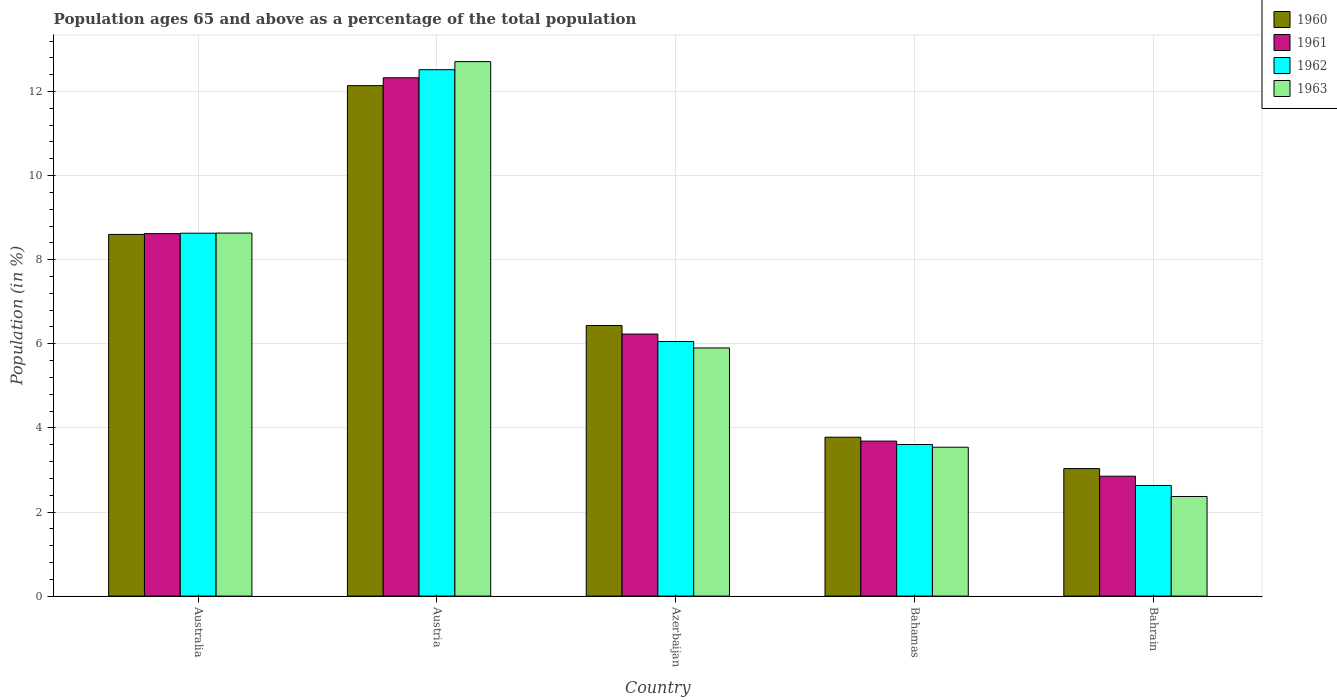How many groups of bars are there?
Keep it short and to the point. 5. How many bars are there on the 2nd tick from the left?
Make the answer very short. 4. How many bars are there on the 4th tick from the right?
Keep it short and to the point. 4. What is the label of the 2nd group of bars from the left?
Give a very brief answer. Austria. In how many cases, is the number of bars for a given country not equal to the number of legend labels?
Offer a very short reply. 0. What is the percentage of the population ages 65 and above in 1963 in Austria?
Ensure brevity in your answer.  12.71. Across all countries, what is the maximum percentage of the population ages 65 and above in 1962?
Give a very brief answer. 12.52. Across all countries, what is the minimum percentage of the population ages 65 and above in 1961?
Offer a terse response. 2.85. In which country was the percentage of the population ages 65 and above in 1962 maximum?
Offer a very short reply. Austria. In which country was the percentage of the population ages 65 and above in 1963 minimum?
Your answer should be compact. Bahrain. What is the total percentage of the population ages 65 and above in 1960 in the graph?
Offer a very short reply. 33.99. What is the difference between the percentage of the population ages 65 and above in 1960 in Bahamas and that in Bahrain?
Ensure brevity in your answer.  0.75. What is the difference between the percentage of the population ages 65 and above in 1963 in Australia and the percentage of the population ages 65 and above in 1960 in Azerbaijan?
Give a very brief answer. 2.2. What is the average percentage of the population ages 65 and above in 1960 per country?
Make the answer very short. 6.8. What is the difference between the percentage of the population ages 65 and above of/in 1961 and percentage of the population ages 65 and above of/in 1963 in Austria?
Offer a terse response. -0.38. What is the ratio of the percentage of the population ages 65 and above in 1960 in Bahamas to that in Bahrain?
Offer a very short reply. 1.25. Is the percentage of the population ages 65 and above in 1961 in Azerbaijan less than that in Bahamas?
Your answer should be very brief. No. Is the difference between the percentage of the population ages 65 and above in 1961 in Austria and Bahrain greater than the difference between the percentage of the population ages 65 and above in 1963 in Austria and Bahrain?
Make the answer very short. No. What is the difference between the highest and the second highest percentage of the population ages 65 and above in 1962?
Ensure brevity in your answer.  -3.89. What is the difference between the highest and the lowest percentage of the population ages 65 and above in 1960?
Keep it short and to the point. 9.11. In how many countries, is the percentage of the population ages 65 and above in 1961 greater than the average percentage of the population ages 65 and above in 1961 taken over all countries?
Your response must be concise. 2. Is the sum of the percentage of the population ages 65 and above in 1960 in Australia and Bahamas greater than the maximum percentage of the population ages 65 and above in 1961 across all countries?
Keep it short and to the point. Yes. What does the 2nd bar from the left in Azerbaijan represents?
Offer a terse response. 1961. What does the 4th bar from the right in Azerbaijan represents?
Make the answer very short. 1960. How many bars are there?
Give a very brief answer. 20. Are all the bars in the graph horizontal?
Ensure brevity in your answer.  No. What is the difference between two consecutive major ticks on the Y-axis?
Provide a succinct answer. 2. Are the values on the major ticks of Y-axis written in scientific E-notation?
Keep it short and to the point. No. Does the graph contain grids?
Give a very brief answer. Yes. How are the legend labels stacked?
Give a very brief answer. Vertical. What is the title of the graph?
Your answer should be compact. Population ages 65 and above as a percentage of the total population. Does "1966" appear as one of the legend labels in the graph?
Offer a terse response. No. What is the label or title of the X-axis?
Ensure brevity in your answer.  Country. What is the Population (in %) in 1960 in Australia?
Your response must be concise. 8.6. What is the Population (in %) of 1961 in Australia?
Provide a short and direct response. 8.62. What is the Population (in %) of 1962 in Australia?
Offer a terse response. 8.63. What is the Population (in %) of 1963 in Australia?
Offer a terse response. 8.63. What is the Population (in %) in 1960 in Austria?
Your answer should be very brief. 12.14. What is the Population (in %) in 1961 in Austria?
Make the answer very short. 12.33. What is the Population (in %) of 1962 in Austria?
Provide a short and direct response. 12.52. What is the Population (in %) in 1963 in Austria?
Your response must be concise. 12.71. What is the Population (in %) in 1960 in Azerbaijan?
Keep it short and to the point. 6.43. What is the Population (in %) of 1961 in Azerbaijan?
Your response must be concise. 6.23. What is the Population (in %) of 1962 in Azerbaijan?
Your answer should be very brief. 6.06. What is the Population (in %) of 1963 in Azerbaijan?
Offer a very short reply. 5.9. What is the Population (in %) of 1960 in Bahamas?
Keep it short and to the point. 3.78. What is the Population (in %) of 1961 in Bahamas?
Offer a very short reply. 3.69. What is the Population (in %) in 1962 in Bahamas?
Offer a very short reply. 3.6. What is the Population (in %) in 1963 in Bahamas?
Your response must be concise. 3.54. What is the Population (in %) of 1960 in Bahrain?
Ensure brevity in your answer.  3.03. What is the Population (in %) of 1961 in Bahrain?
Offer a very short reply. 2.85. What is the Population (in %) in 1962 in Bahrain?
Ensure brevity in your answer.  2.63. What is the Population (in %) in 1963 in Bahrain?
Your answer should be compact. 2.37. Across all countries, what is the maximum Population (in %) in 1960?
Provide a succinct answer. 12.14. Across all countries, what is the maximum Population (in %) of 1961?
Offer a terse response. 12.33. Across all countries, what is the maximum Population (in %) in 1962?
Make the answer very short. 12.52. Across all countries, what is the maximum Population (in %) of 1963?
Give a very brief answer. 12.71. Across all countries, what is the minimum Population (in %) of 1960?
Give a very brief answer. 3.03. Across all countries, what is the minimum Population (in %) of 1961?
Your response must be concise. 2.85. Across all countries, what is the minimum Population (in %) in 1962?
Make the answer very short. 2.63. Across all countries, what is the minimum Population (in %) of 1963?
Keep it short and to the point. 2.37. What is the total Population (in %) in 1960 in the graph?
Give a very brief answer. 33.99. What is the total Population (in %) of 1961 in the graph?
Your response must be concise. 33.72. What is the total Population (in %) of 1962 in the graph?
Your answer should be compact. 33.44. What is the total Population (in %) of 1963 in the graph?
Ensure brevity in your answer.  33.16. What is the difference between the Population (in %) in 1960 in Australia and that in Austria?
Make the answer very short. -3.54. What is the difference between the Population (in %) of 1961 in Australia and that in Austria?
Provide a short and direct response. -3.71. What is the difference between the Population (in %) of 1962 in Australia and that in Austria?
Provide a short and direct response. -3.89. What is the difference between the Population (in %) in 1963 in Australia and that in Austria?
Your answer should be very brief. -4.08. What is the difference between the Population (in %) in 1960 in Australia and that in Azerbaijan?
Your answer should be very brief. 2.17. What is the difference between the Population (in %) in 1961 in Australia and that in Azerbaijan?
Make the answer very short. 2.39. What is the difference between the Population (in %) in 1962 in Australia and that in Azerbaijan?
Your answer should be compact. 2.58. What is the difference between the Population (in %) of 1963 in Australia and that in Azerbaijan?
Your response must be concise. 2.73. What is the difference between the Population (in %) of 1960 in Australia and that in Bahamas?
Give a very brief answer. 4.82. What is the difference between the Population (in %) in 1961 in Australia and that in Bahamas?
Give a very brief answer. 4.93. What is the difference between the Population (in %) of 1962 in Australia and that in Bahamas?
Offer a terse response. 5.03. What is the difference between the Population (in %) of 1963 in Australia and that in Bahamas?
Ensure brevity in your answer.  5.09. What is the difference between the Population (in %) in 1960 in Australia and that in Bahrain?
Your answer should be very brief. 5.57. What is the difference between the Population (in %) in 1961 in Australia and that in Bahrain?
Keep it short and to the point. 5.77. What is the difference between the Population (in %) of 1962 in Australia and that in Bahrain?
Offer a very short reply. 6. What is the difference between the Population (in %) of 1963 in Australia and that in Bahrain?
Give a very brief answer. 6.26. What is the difference between the Population (in %) of 1960 in Austria and that in Azerbaijan?
Ensure brevity in your answer.  5.71. What is the difference between the Population (in %) of 1961 in Austria and that in Azerbaijan?
Your answer should be compact. 6.09. What is the difference between the Population (in %) of 1962 in Austria and that in Azerbaijan?
Ensure brevity in your answer.  6.46. What is the difference between the Population (in %) in 1963 in Austria and that in Azerbaijan?
Offer a terse response. 6.81. What is the difference between the Population (in %) in 1960 in Austria and that in Bahamas?
Provide a succinct answer. 8.36. What is the difference between the Population (in %) of 1961 in Austria and that in Bahamas?
Ensure brevity in your answer.  8.64. What is the difference between the Population (in %) of 1962 in Austria and that in Bahamas?
Give a very brief answer. 8.91. What is the difference between the Population (in %) of 1963 in Austria and that in Bahamas?
Give a very brief answer. 9.17. What is the difference between the Population (in %) of 1960 in Austria and that in Bahrain?
Provide a succinct answer. 9.11. What is the difference between the Population (in %) of 1961 in Austria and that in Bahrain?
Offer a very short reply. 9.48. What is the difference between the Population (in %) of 1962 in Austria and that in Bahrain?
Provide a succinct answer. 9.89. What is the difference between the Population (in %) in 1963 in Austria and that in Bahrain?
Provide a short and direct response. 10.34. What is the difference between the Population (in %) of 1960 in Azerbaijan and that in Bahamas?
Offer a terse response. 2.66. What is the difference between the Population (in %) in 1961 in Azerbaijan and that in Bahamas?
Provide a succinct answer. 2.55. What is the difference between the Population (in %) in 1962 in Azerbaijan and that in Bahamas?
Offer a very short reply. 2.45. What is the difference between the Population (in %) in 1963 in Azerbaijan and that in Bahamas?
Make the answer very short. 2.36. What is the difference between the Population (in %) in 1960 in Azerbaijan and that in Bahrain?
Provide a short and direct response. 3.4. What is the difference between the Population (in %) of 1961 in Azerbaijan and that in Bahrain?
Provide a succinct answer. 3.38. What is the difference between the Population (in %) of 1962 in Azerbaijan and that in Bahrain?
Offer a very short reply. 3.42. What is the difference between the Population (in %) of 1963 in Azerbaijan and that in Bahrain?
Provide a short and direct response. 3.53. What is the difference between the Population (in %) in 1960 in Bahamas and that in Bahrain?
Your answer should be very brief. 0.75. What is the difference between the Population (in %) of 1961 in Bahamas and that in Bahrain?
Provide a succinct answer. 0.83. What is the difference between the Population (in %) in 1962 in Bahamas and that in Bahrain?
Your answer should be compact. 0.97. What is the difference between the Population (in %) of 1963 in Bahamas and that in Bahrain?
Give a very brief answer. 1.17. What is the difference between the Population (in %) of 1960 in Australia and the Population (in %) of 1961 in Austria?
Offer a very short reply. -3.72. What is the difference between the Population (in %) in 1960 in Australia and the Population (in %) in 1962 in Austria?
Your answer should be compact. -3.92. What is the difference between the Population (in %) in 1960 in Australia and the Population (in %) in 1963 in Austria?
Your answer should be very brief. -4.11. What is the difference between the Population (in %) of 1961 in Australia and the Population (in %) of 1962 in Austria?
Your response must be concise. -3.9. What is the difference between the Population (in %) of 1961 in Australia and the Population (in %) of 1963 in Austria?
Give a very brief answer. -4.09. What is the difference between the Population (in %) of 1962 in Australia and the Population (in %) of 1963 in Austria?
Your answer should be compact. -4.08. What is the difference between the Population (in %) of 1960 in Australia and the Population (in %) of 1961 in Azerbaijan?
Ensure brevity in your answer.  2.37. What is the difference between the Population (in %) in 1960 in Australia and the Population (in %) in 1962 in Azerbaijan?
Offer a terse response. 2.55. What is the difference between the Population (in %) in 1960 in Australia and the Population (in %) in 1963 in Azerbaijan?
Make the answer very short. 2.7. What is the difference between the Population (in %) in 1961 in Australia and the Population (in %) in 1962 in Azerbaijan?
Your answer should be compact. 2.57. What is the difference between the Population (in %) of 1961 in Australia and the Population (in %) of 1963 in Azerbaijan?
Give a very brief answer. 2.72. What is the difference between the Population (in %) in 1962 in Australia and the Population (in %) in 1963 in Azerbaijan?
Ensure brevity in your answer.  2.73. What is the difference between the Population (in %) of 1960 in Australia and the Population (in %) of 1961 in Bahamas?
Provide a succinct answer. 4.92. What is the difference between the Population (in %) of 1960 in Australia and the Population (in %) of 1962 in Bahamas?
Provide a succinct answer. 5. What is the difference between the Population (in %) of 1960 in Australia and the Population (in %) of 1963 in Bahamas?
Your response must be concise. 5.06. What is the difference between the Population (in %) in 1961 in Australia and the Population (in %) in 1962 in Bahamas?
Provide a short and direct response. 5.02. What is the difference between the Population (in %) in 1961 in Australia and the Population (in %) in 1963 in Bahamas?
Your answer should be compact. 5.08. What is the difference between the Population (in %) of 1962 in Australia and the Population (in %) of 1963 in Bahamas?
Make the answer very short. 5.09. What is the difference between the Population (in %) in 1960 in Australia and the Population (in %) in 1961 in Bahrain?
Ensure brevity in your answer.  5.75. What is the difference between the Population (in %) in 1960 in Australia and the Population (in %) in 1962 in Bahrain?
Make the answer very short. 5.97. What is the difference between the Population (in %) in 1960 in Australia and the Population (in %) in 1963 in Bahrain?
Provide a short and direct response. 6.23. What is the difference between the Population (in %) of 1961 in Australia and the Population (in %) of 1962 in Bahrain?
Offer a very short reply. 5.99. What is the difference between the Population (in %) of 1961 in Australia and the Population (in %) of 1963 in Bahrain?
Offer a terse response. 6.25. What is the difference between the Population (in %) in 1962 in Australia and the Population (in %) in 1963 in Bahrain?
Your answer should be very brief. 6.26. What is the difference between the Population (in %) in 1960 in Austria and the Population (in %) in 1961 in Azerbaijan?
Give a very brief answer. 5.91. What is the difference between the Population (in %) of 1960 in Austria and the Population (in %) of 1962 in Azerbaijan?
Your response must be concise. 6.08. What is the difference between the Population (in %) of 1960 in Austria and the Population (in %) of 1963 in Azerbaijan?
Your response must be concise. 6.24. What is the difference between the Population (in %) in 1961 in Austria and the Population (in %) in 1962 in Azerbaijan?
Provide a short and direct response. 6.27. What is the difference between the Population (in %) in 1961 in Austria and the Population (in %) in 1963 in Azerbaijan?
Your response must be concise. 6.43. What is the difference between the Population (in %) of 1962 in Austria and the Population (in %) of 1963 in Azerbaijan?
Your response must be concise. 6.62. What is the difference between the Population (in %) of 1960 in Austria and the Population (in %) of 1961 in Bahamas?
Make the answer very short. 8.45. What is the difference between the Population (in %) in 1960 in Austria and the Population (in %) in 1962 in Bahamas?
Provide a short and direct response. 8.54. What is the difference between the Population (in %) in 1960 in Austria and the Population (in %) in 1963 in Bahamas?
Ensure brevity in your answer.  8.6. What is the difference between the Population (in %) of 1961 in Austria and the Population (in %) of 1962 in Bahamas?
Offer a terse response. 8.72. What is the difference between the Population (in %) of 1961 in Austria and the Population (in %) of 1963 in Bahamas?
Keep it short and to the point. 8.79. What is the difference between the Population (in %) in 1962 in Austria and the Population (in %) in 1963 in Bahamas?
Keep it short and to the point. 8.98. What is the difference between the Population (in %) of 1960 in Austria and the Population (in %) of 1961 in Bahrain?
Provide a short and direct response. 9.29. What is the difference between the Population (in %) of 1960 in Austria and the Population (in %) of 1962 in Bahrain?
Your answer should be compact. 9.51. What is the difference between the Population (in %) of 1960 in Austria and the Population (in %) of 1963 in Bahrain?
Ensure brevity in your answer.  9.77. What is the difference between the Population (in %) in 1961 in Austria and the Population (in %) in 1962 in Bahrain?
Your answer should be compact. 9.7. What is the difference between the Population (in %) of 1961 in Austria and the Population (in %) of 1963 in Bahrain?
Offer a very short reply. 9.96. What is the difference between the Population (in %) of 1962 in Austria and the Population (in %) of 1963 in Bahrain?
Your response must be concise. 10.15. What is the difference between the Population (in %) of 1960 in Azerbaijan and the Population (in %) of 1961 in Bahamas?
Offer a terse response. 2.75. What is the difference between the Population (in %) of 1960 in Azerbaijan and the Population (in %) of 1962 in Bahamas?
Provide a succinct answer. 2.83. What is the difference between the Population (in %) in 1960 in Azerbaijan and the Population (in %) in 1963 in Bahamas?
Give a very brief answer. 2.89. What is the difference between the Population (in %) in 1961 in Azerbaijan and the Population (in %) in 1962 in Bahamas?
Your answer should be very brief. 2.63. What is the difference between the Population (in %) in 1961 in Azerbaijan and the Population (in %) in 1963 in Bahamas?
Offer a terse response. 2.69. What is the difference between the Population (in %) in 1962 in Azerbaijan and the Population (in %) in 1963 in Bahamas?
Ensure brevity in your answer.  2.52. What is the difference between the Population (in %) in 1960 in Azerbaijan and the Population (in %) in 1961 in Bahrain?
Ensure brevity in your answer.  3.58. What is the difference between the Population (in %) in 1960 in Azerbaijan and the Population (in %) in 1962 in Bahrain?
Give a very brief answer. 3.8. What is the difference between the Population (in %) in 1960 in Azerbaijan and the Population (in %) in 1963 in Bahrain?
Your answer should be very brief. 4.07. What is the difference between the Population (in %) of 1961 in Azerbaijan and the Population (in %) of 1962 in Bahrain?
Offer a terse response. 3.6. What is the difference between the Population (in %) in 1961 in Azerbaijan and the Population (in %) in 1963 in Bahrain?
Offer a very short reply. 3.86. What is the difference between the Population (in %) of 1962 in Azerbaijan and the Population (in %) of 1963 in Bahrain?
Give a very brief answer. 3.69. What is the difference between the Population (in %) of 1960 in Bahamas and the Population (in %) of 1961 in Bahrain?
Ensure brevity in your answer.  0.93. What is the difference between the Population (in %) in 1960 in Bahamas and the Population (in %) in 1962 in Bahrain?
Your response must be concise. 1.15. What is the difference between the Population (in %) in 1960 in Bahamas and the Population (in %) in 1963 in Bahrain?
Provide a succinct answer. 1.41. What is the difference between the Population (in %) of 1961 in Bahamas and the Population (in %) of 1962 in Bahrain?
Ensure brevity in your answer.  1.06. What is the difference between the Population (in %) of 1961 in Bahamas and the Population (in %) of 1963 in Bahrain?
Give a very brief answer. 1.32. What is the difference between the Population (in %) in 1962 in Bahamas and the Population (in %) in 1963 in Bahrain?
Your response must be concise. 1.24. What is the average Population (in %) of 1960 per country?
Your response must be concise. 6.8. What is the average Population (in %) of 1961 per country?
Provide a short and direct response. 6.74. What is the average Population (in %) in 1962 per country?
Give a very brief answer. 6.69. What is the average Population (in %) of 1963 per country?
Ensure brevity in your answer.  6.63. What is the difference between the Population (in %) of 1960 and Population (in %) of 1961 in Australia?
Provide a short and direct response. -0.02. What is the difference between the Population (in %) in 1960 and Population (in %) in 1962 in Australia?
Offer a terse response. -0.03. What is the difference between the Population (in %) in 1960 and Population (in %) in 1963 in Australia?
Ensure brevity in your answer.  -0.03. What is the difference between the Population (in %) of 1961 and Population (in %) of 1962 in Australia?
Offer a very short reply. -0.01. What is the difference between the Population (in %) of 1961 and Population (in %) of 1963 in Australia?
Give a very brief answer. -0.01. What is the difference between the Population (in %) in 1962 and Population (in %) in 1963 in Australia?
Your answer should be compact. -0. What is the difference between the Population (in %) of 1960 and Population (in %) of 1961 in Austria?
Your response must be concise. -0.19. What is the difference between the Population (in %) of 1960 and Population (in %) of 1962 in Austria?
Provide a succinct answer. -0.38. What is the difference between the Population (in %) in 1960 and Population (in %) in 1963 in Austria?
Provide a short and direct response. -0.57. What is the difference between the Population (in %) in 1961 and Population (in %) in 1962 in Austria?
Offer a terse response. -0.19. What is the difference between the Population (in %) in 1961 and Population (in %) in 1963 in Austria?
Offer a very short reply. -0.38. What is the difference between the Population (in %) of 1962 and Population (in %) of 1963 in Austria?
Offer a terse response. -0.19. What is the difference between the Population (in %) of 1960 and Population (in %) of 1961 in Azerbaijan?
Give a very brief answer. 0.2. What is the difference between the Population (in %) of 1960 and Population (in %) of 1962 in Azerbaijan?
Offer a terse response. 0.38. What is the difference between the Population (in %) of 1960 and Population (in %) of 1963 in Azerbaijan?
Your response must be concise. 0.53. What is the difference between the Population (in %) of 1961 and Population (in %) of 1962 in Azerbaijan?
Your response must be concise. 0.18. What is the difference between the Population (in %) of 1961 and Population (in %) of 1963 in Azerbaijan?
Provide a short and direct response. 0.33. What is the difference between the Population (in %) of 1962 and Population (in %) of 1963 in Azerbaijan?
Keep it short and to the point. 0.15. What is the difference between the Population (in %) of 1960 and Population (in %) of 1961 in Bahamas?
Ensure brevity in your answer.  0.09. What is the difference between the Population (in %) in 1960 and Population (in %) in 1962 in Bahamas?
Your answer should be compact. 0.17. What is the difference between the Population (in %) in 1960 and Population (in %) in 1963 in Bahamas?
Your answer should be very brief. 0.24. What is the difference between the Population (in %) of 1961 and Population (in %) of 1962 in Bahamas?
Ensure brevity in your answer.  0.08. What is the difference between the Population (in %) in 1961 and Population (in %) in 1963 in Bahamas?
Your answer should be very brief. 0.15. What is the difference between the Population (in %) of 1962 and Population (in %) of 1963 in Bahamas?
Give a very brief answer. 0.06. What is the difference between the Population (in %) of 1960 and Population (in %) of 1961 in Bahrain?
Offer a terse response. 0.18. What is the difference between the Population (in %) in 1960 and Population (in %) in 1962 in Bahrain?
Provide a short and direct response. 0.4. What is the difference between the Population (in %) of 1960 and Population (in %) of 1963 in Bahrain?
Provide a short and direct response. 0.66. What is the difference between the Population (in %) in 1961 and Population (in %) in 1962 in Bahrain?
Your response must be concise. 0.22. What is the difference between the Population (in %) in 1961 and Population (in %) in 1963 in Bahrain?
Your answer should be very brief. 0.48. What is the difference between the Population (in %) in 1962 and Population (in %) in 1963 in Bahrain?
Provide a short and direct response. 0.26. What is the ratio of the Population (in %) of 1960 in Australia to that in Austria?
Provide a short and direct response. 0.71. What is the ratio of the Population (in %) of 1961 in Australia to that in Austria?
Give a very brief answer. 0.7. What is the ratio of the Population (in %) of 1962 in Australia to that in Austria?
Offer a terse response. 0.69. What is the ratio of the Population (in %) in 1963 in Australia to that in Austria?
Your response must be concise. 0.68. What is the ratio of the Population (in %) of 1960 in Australia to that in Azerbaijan?
Offer a very short reply. 1.34. What is the ratio of the Population (in %) in 1961 in Australia to that in Azerbaijan?
Provide a short and direct response. 1.38. What is the ratio of the Population (in %) in 1962 in Australia to that in Azerbaijan?
Give a very brief answer. 1.43. What is the ratio of the Population (in %) of 1963 in Australia to that in Azerbaijan?
Provide a short and direct response. 1.46. What is the ratio of the Population (in %) in 1960 in Australia to that in Bahamas?
Your answer should be very brief. 2.28. What is the ratio of the Population (in %) in 1961 in Australia to that in Bahamas?
Make the answer very short. 2.34. What is the ratio of the Population (in %) of 1962 in Australia to that in Bahamas?
Keep it short and to the point. 2.39. What is the ratio of the Population (in %) of 1963 in Australia to that in Bahamas?
Ensure brevity in your answer.  2.44. What is the ratio of the Population (in %) in 1960 in Australia to that in Bahrain?
Make the answer very short. 2.84. What is the ratio of the Population (in %) of 1961 in Australia to that in Bahrain?
Provide a succinct answer. 3.02. What is the ratio of the Population (in %) of 1962 in Australia to that in Bahrain?
Give a very brief answer. 3.28. What is the ratio of the Population (in %) in 1963 in Australia to that in Bahrain?
Your response must be concise. 3.64. What is the ratio of the Population (in %) in 1960 in Austria to that in Azerbaijan?
Keep it short and to the point. 1.89. What is the ratio of the Population (in %) in 1961 in Austria to that in Azerbaijan?
Give a very brief answer. 1.98. What is the ratio of the Population (in %) of 1962 in Austria to that in Azerbaijan?
Provide a short and direct response. 2.07. What is the ratio of the Population (in %) of 1963 in Austria to that in Azerbaijan?
Keep it short and to the point. 2.15. What is the ratio of the Population (in %) of 1960 in Austria to that in Bahamas?
Offer a very short reply. 3.21. What is the ratio of the Population (in %) of 1961 in Austria to that in Bahamas?
Offer a terse response. 3.34. What is the ratio of the Population (in %) of 1962 in Austria to that in Bahamas?
Your answer should be very brief. 3.47. What is the ratio of the Population (in %) of 1963 in Austria to that in Bahamas?
Offer a very short reply. 3.59. What is the ratio of the Population (in %) in 1960 in Austria to that in Bahrain?
Ensure brevity in your answer.  4. What is the ratio of the Population (in %) of 1961 in Austria to that in Bahrain?
Your response must be concise. 4.32. What is the ratio of the Population (in %) in 1962 in Austria to that in Bahrain?
Keep it short and to the point. 4.76. What is the ratio of the Population (in %) of 1963 in Austria to that in Bahrain?
Keep it short and to the point. 5.37. What is the ratio of the Population (in %) of 1960 in Azerbaijan to that in Bahamas?
Offer a terse response. 1.7. What is the ratio of the Population (in %) in 1961 in Azerbaijan to that in Bahamas?
Your answer should be very brief. 1.69. What is the ratio of the Population (in %) of 1962 in Azerbaijan to that in Bahamas?
Provide a short and direct response. 1.68. What is the ratio of the Population (in %) in 1963 in Azerbaijan to that in Bahamas?
Provide a succinct answer. 1.67. What is the ratio of the Population (in %) of 1960 in Azerbaijan to that in Bahrain?
Give a very brief answer. 2.12. What is the ratio of the Population (in %) of 1961 in Azerbaijan to that in Bahrain?
Your answer should be very brief. 2.19. What is the ratio of the Population (in %) in 1962 in Azerbaijan to that in Bahrain?
Keep it short and to the point. 2.3. What is the ratio of the Population (in %) in 1963 in Azerbaijan to that in Bahrain?
Your answer should be compact. 2.49. What is the ratio of the Population (in %) in 1960 in Bahamas to that in Bahrain?
Give a very brief answer. 1.25. What is the ratio of the Population (in %) in 1961 in Bahamas to that in Bahrain?
Make the answer very short. 1.29. What is the ratio of the Population (in %) of 1962 in Bahamas to that in Bahrain?
Your response must be concise. 1.37. What is the ratio of the Population (in %) in 1963 in Bahamas to that in Bahrain?
Provide a succinct answer. 1.49. What is the difference between the highest and the second highest Population (in %) of 1960?
Your answer should be compact. 3.54. What is the difference between the highest and the second highest Population (in %) of 1961?
Provide a succinct answer. 3.71. What is the difference between the highest and the second highest Population (in %) in 1962?
Your response must be concise. 3.89. What is the difference between the highest and the second highest Population (in %) in 1963?
Provide a succinct answer. 4.08. What is the difference between the highest and the lowest Population (in %) in 1960?
Your answer should be compact. 9.11. What is the difference between the highest and the lowest Population (in %) in 1961?
Offer a terse response. 9.48. What is the difference between the highest and the lowest Population (in %) of 1962?
Offer a very short reply. 9.89. What is the difference between the highest and the lowest Population (in %) in 1963?
Provide a short and direct response. 10.34. 